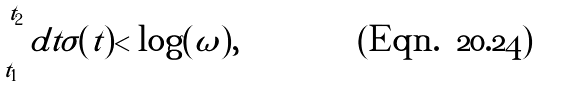<formula> <loc_0><loc_0><loc_500><loc_500>\int _ { t _ { 1 } } ^ { t _ { 2 } } d t \sigma ( t ) < \log ( \omega ) ,</formula> 